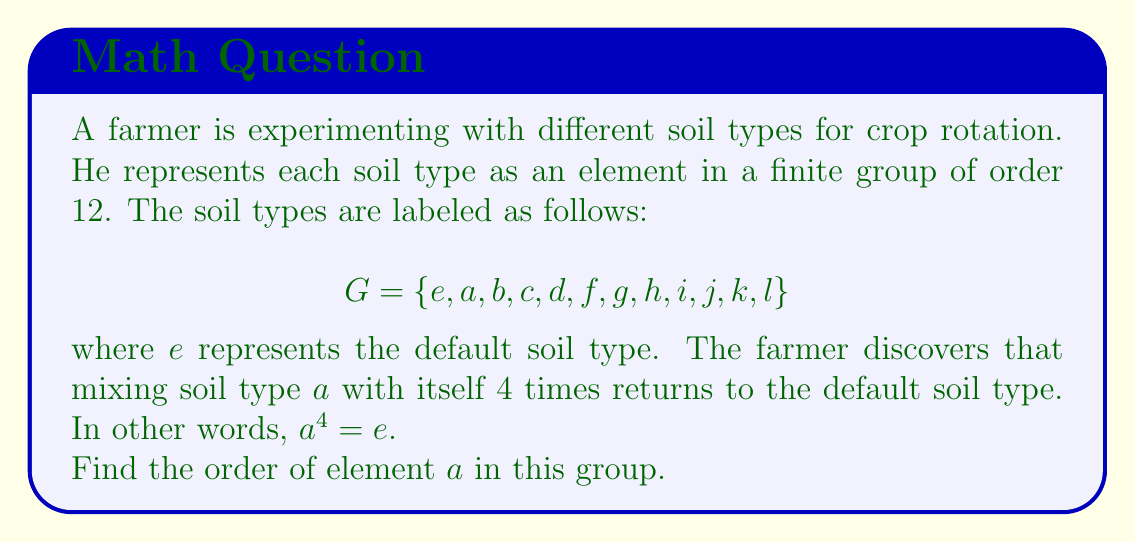Help me with this question. To find the order of element $a$ in the group $G$, we need to determine the smallest positive integer $n$ such that $a^n = e$, where $e$ is the identity element of the group.

Given information:
1. The group $G$ has order 12.
2. $a^4 = e$

Step 1: Consider the possible orders for element $a$.
The order of an element must divide the order of the group. The divisors of 12 are 1, 2, 3, 4, 6, and 12.

Step 2: Eliminate impossible orders.
- The order cannot be 1, as $a \neq e$.
- The order cannot be 2 or 3, as $a^4 = e$ implies that $a^2 \neq e$ and $a^3 \neq e$.
- The order cannot be 6 or 12, as we know $a^4 = e$.

Step 3: Conclude the order of $a$.
The only remaining possibility is 4. This matches the given information that $a^4 = e$.

Therefore, the order of element $a$ is 4.
Answer: The order of element $a$ is 4. 